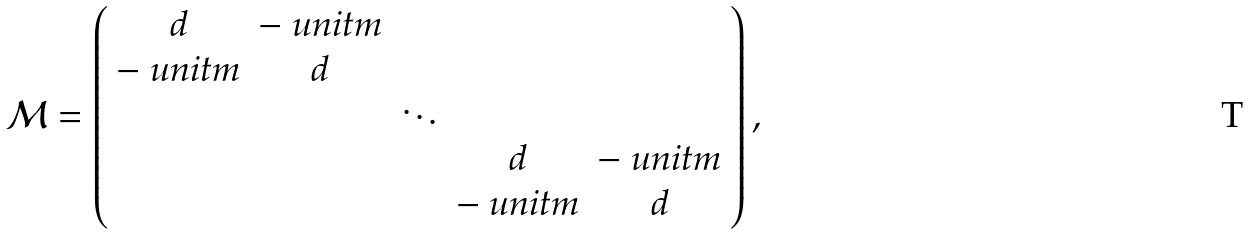Convert formula to latex. <formula><loc_0><loc_0><loc_500><loc_500>\mathcal { M } = \left ( \begin{array} { c c c c c } d & - \ u n i t m & & & \\ - \ u n i t m & d & & & \\ & & \ddots & & \\ & & & d & - \ u n i t m \\ & & & - \ u n i t m & d \end{array} \right ) ,</formula> 